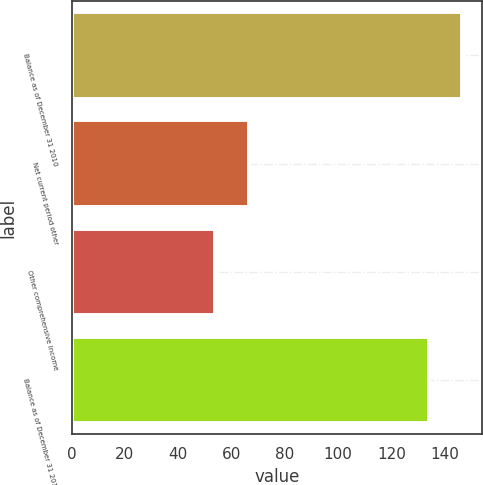<chart> <loc_0><loc_0><loc_500><loc_500><bar_chart><fcel>Balance as of December 31 2010<fcel>Net current period other<fcel>Other comprehensive income<fcel>Balance as of December 31 2013<nl><fcel>146.7<fcel>66.7<fcel>54<fcel>134<nl></chart> 